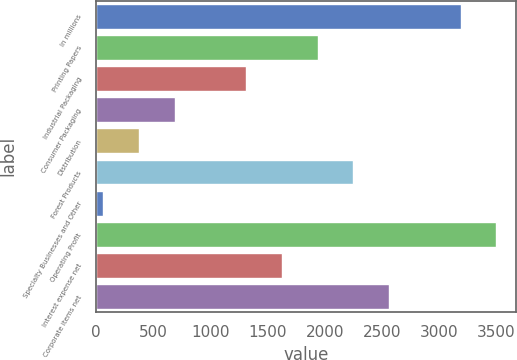Convert chart to OTSL. <chart><loc_0><loc_0><loc_500><loc_500><bar_chart><fcel>In millions<fcel>Printing Papers<fcel>Industrial Packaging<fcel>Consumer Packaging<fcel>Distribution<fcel>Forest Products<fcel>Specialty Businesses and Other<fcel>Operating Profit<fcel>Interest expense net<fcel>Corporate items net<nl><fcel>3188<fcel>1937.2<fcel>1311.8<fcel>686.4<fcel>373.7<fcel>2249.9<fcel>61<fcel>3500.7<fcel>1624.5<fcel>2562.6<nl></chart> 